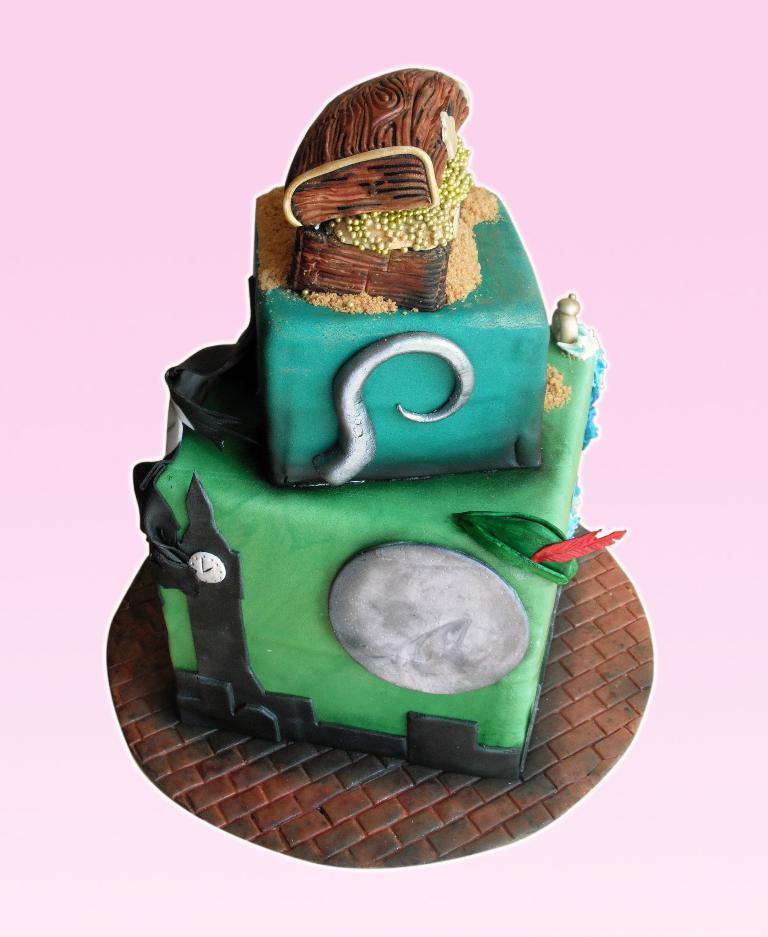How would you summarize this image in a sentence or two? This is an edited image. In this image I can see a cake. 